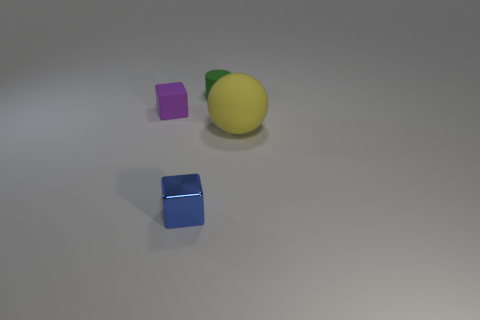Add 2 tiny matte cubes. How many objects exist? 6 Subtract all cylinders. How many objects are left? 3 Add 1 brown matte blocks. How many brown matte blocks exist? 1 Subtract 0 green cubes. How many objects are left? 4 Subtract all gray metal balls. Subtract all large matte objects. How many objects are left? 3 Add 4 large yellow objects. How many large yellow objects are left? 5 